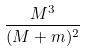<formula> <loc_0><loc_0><loc_500><loc_500>\frac { M ^ { 3 } } { ( M + m ) ^ { 2 } }</formula> 